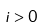<formula> <loc_0><loc_0><loc_500><loc_500>i > 0</formula> 